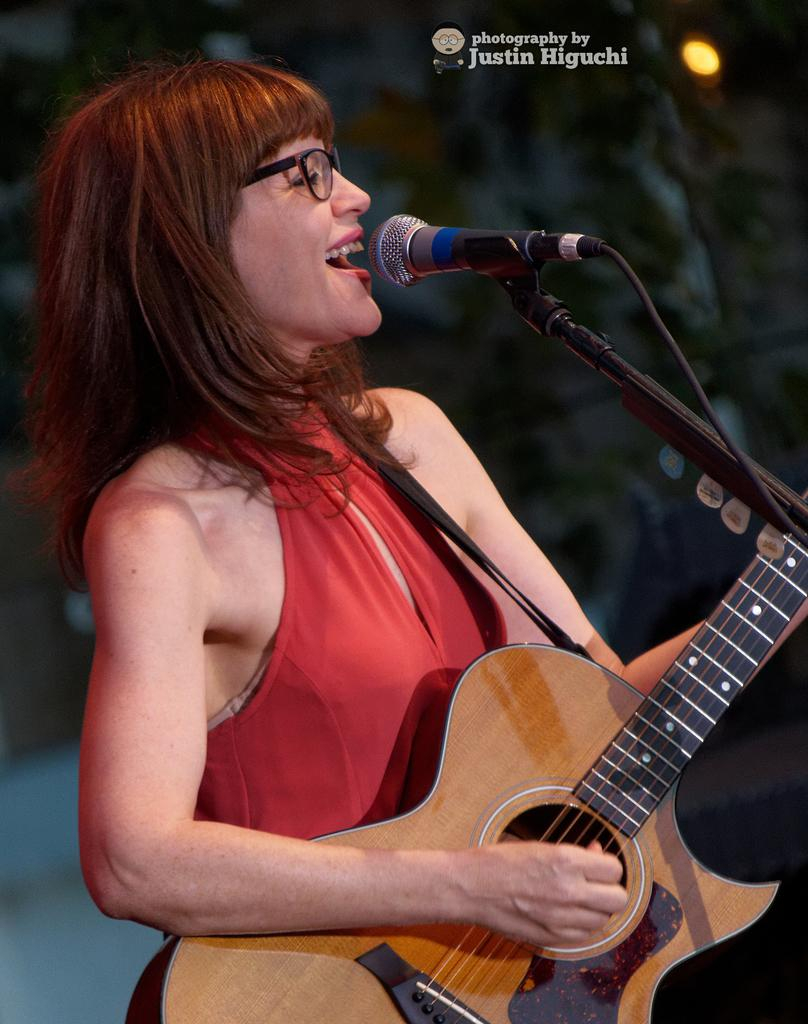Who is the main subject in the image? There is a girl in the image. What is the girl wearing? The girl is wearing a red dress and spectacles. What is the girl holding in the image? The girl is holding a guitar. What activity is the girl engaged in? The girl is singing in front of a microphone. What time of day is it in the image? The provided facts do not mention the time of day, so it cannot be determined from the image. Are there any nails visible in the image? There are no nails mentioned or visible in the image. 